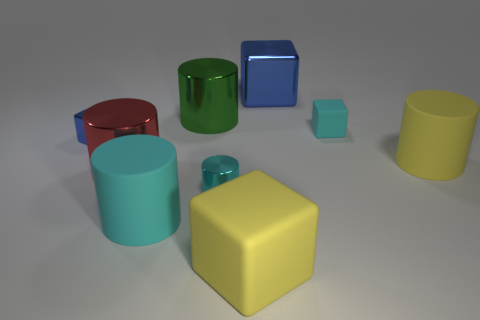Subtract all yellow cylinders. How many cylinders are left? 4 Subtract all green cylinders. How many cylinders are left? 4 Subtract all gray blocks. Subtract all green cylinders. How many blocks are left? 4 Subtract all cylinders. How many objects are left? 4 Add 9 small cyan metallic objects. How many small cyan metallic objects are left? 10 Add 7 tiny metallic blocks. How many tiny metallic blocks exist? 8 Subtract 0 green balls. How many objects are left? 9 Subtract all big matte objects. Subtract all large yellow blocks. How many objects are left? 5 